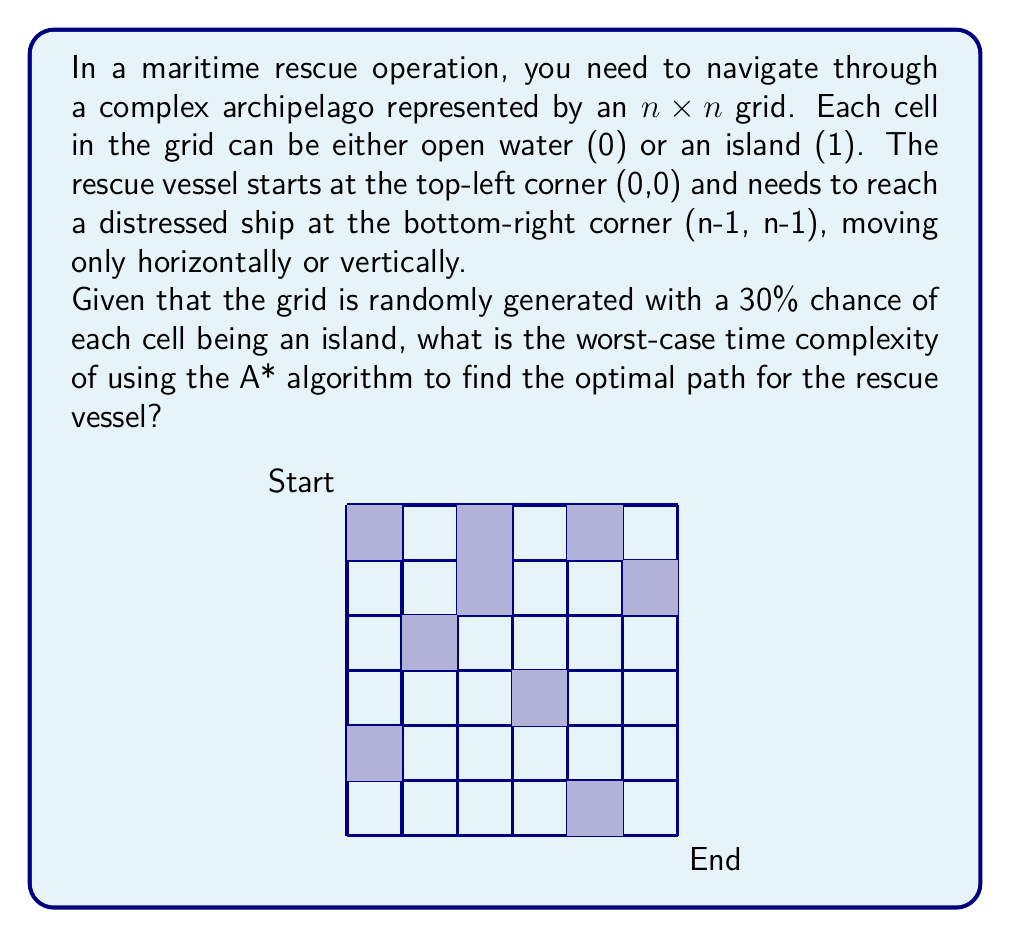Show me your answer to this math problem. To determine the worst-case time complexity of the A* algorithm in this scenario, we need to consider the following factors:

1. Grid size: The grid is $n \times n$, so there are $n^2$ total cells.

2. Branching factor: In each step, the vessel can move in up to 4 directions (up, down, left, right).

3. Heuristic function: We can use the Manhattan distance as a heuristic, which is admissible and consistent for this grid-based problem.

4. Worst-case scenario: The worst case occurs when the algorithm needs to explore almost all cells before finding the goal.

5. Priority queue operations: A* uses a priority queue to select the next node to expand.

Step-by-step analysis:

1. In the worst case, A* may need to explore almost all $n^2$ cells.

2. For each cell, we perform the following operations:
   a. Remove the cell from the priority queue: $O(\log(n^2)) = O(\log n)$
   b. Generate up to 4 neighbors: $O(1)$
   c. For each neighbor, calculate $f = g + h$: $O(1)$
   d. Add each neighbor to the priority queue: $O(\log(n^2)) = O(\log n)$

3. The total operations per cell are $O(\log n)$, dominated by the priority queue operations.

4. Since we may need to explore all $n^2$ cells, the overall time complexity is:

   $$O(n^2 \log n)$$

5. The space complexity is also $O(n^2)$ to store the grid and the priority queue.

It's worth noting that this is a pessimistic upper bound. In practice, the A* algorithm with a good heuristic often performs much better, especially in open spaces. However, in a complex archipelago with many islands, the worst-case scenario becomes more likely.
Answer: $O(n^2 \log n)$ 